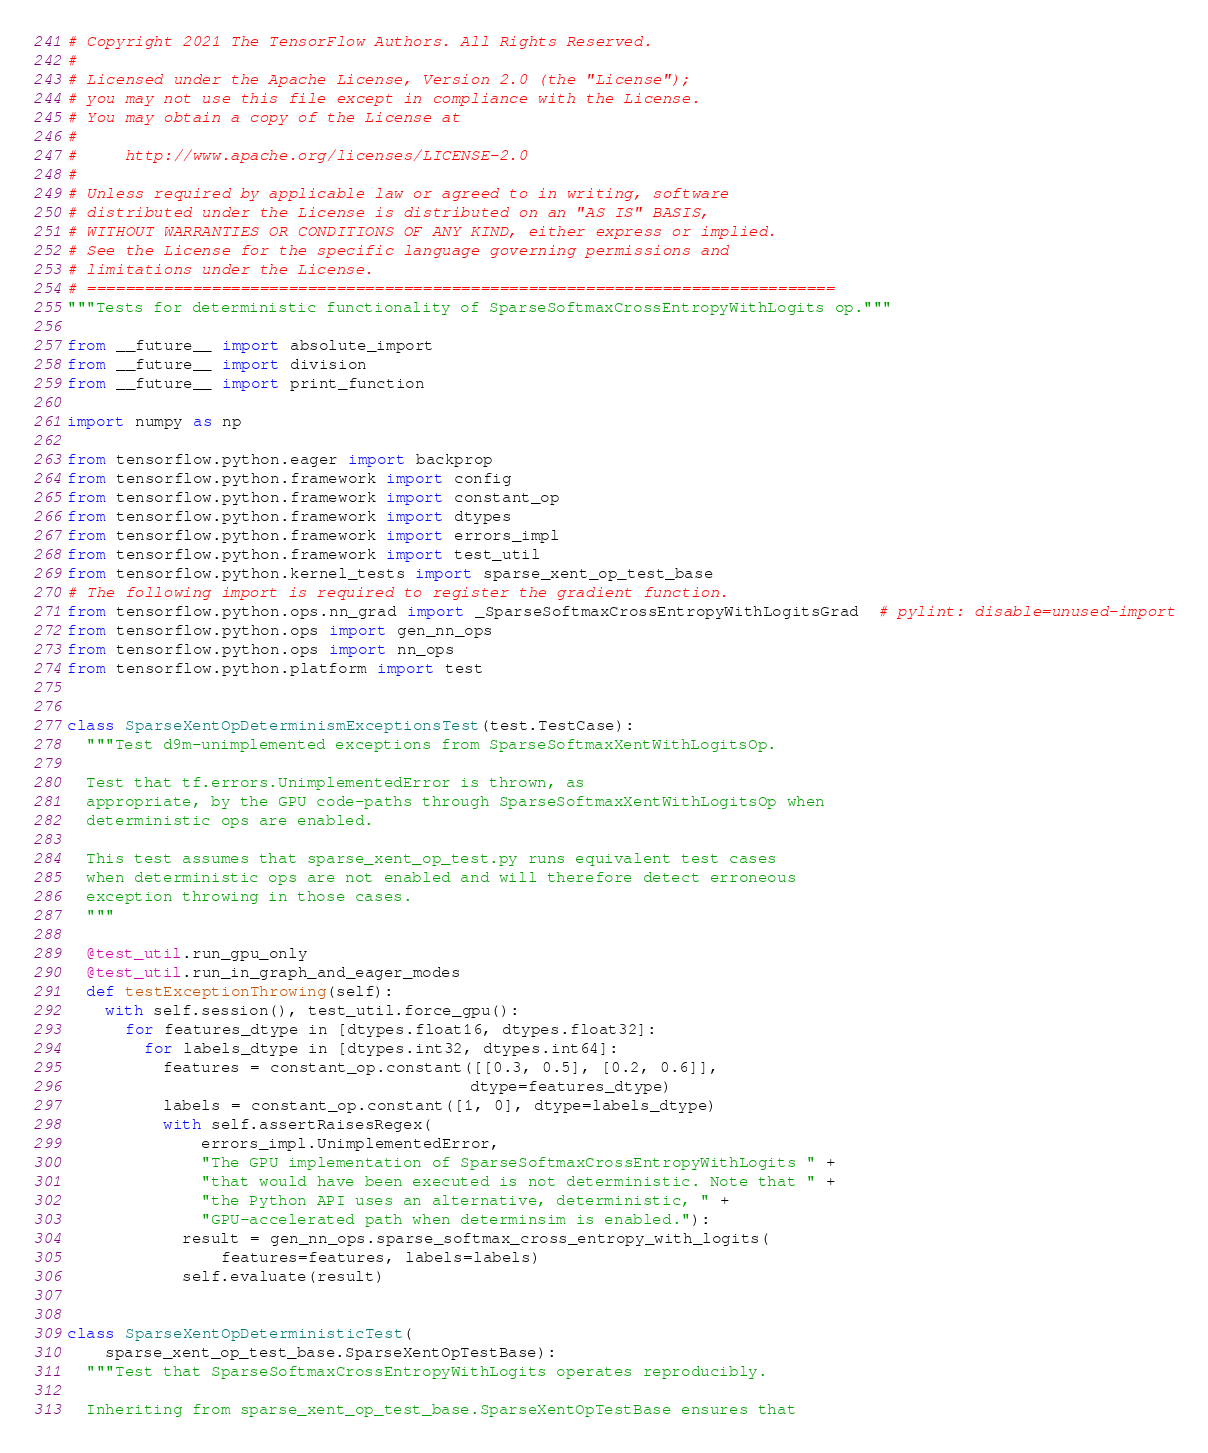Convert code to text. <code><loc_0><loc_0><loc_500><loc_500><_Python_># Copyright 2021 The TensorFlow Authors. All Rights Reserved.
#
# Licensed under the Apache License, Version 2.0 (the "License");
# you may not use this file except in compliance with the License.
# You may obtain a copy of the License at
#
#     http://www.apache.org/licenses/LICENSE-2.0
#
# Unless required by applicable law or agreed to in writing, software
# distributed under the License is distributed on an "AS IS" BASIS,
# WITHOUT WARRANTIES OR CONDITIONS OF ANY KIND, either express or implied.
# See the License for the specific language governing permissions and
# limitations under the License.
# ==============================================================================
"""Tests for deterministic functionality of SparseSoftmaxCrossEntropyWithLogits op."""

from __future__ import absolute_import
from __future__ import division
from __future__ import print_function

import numpy as np

from tensorflow.python.eager import backprop
from tensorflow.python.framework import config
from tensorflow.python.framework import constant_op
from tensorflow.python.framework import dtypes
from tensorflow.python.framework import errors_impl
from tensorflow.python.framework import test_util
from tensorflow.python.kernel_tests import sparse_xent_op_test_base
# The following import is required to register the gradient function.
from tensorflow.python.ops.nn_grad import _SparseSoftmaxCrossEntropyWithLogitsGrad  # pylint: disable=unused-import
from tensorflow.python.ops import gen_nn_ops
from tensorflow.python.ops import nn_ops
from tensorflow.python.platform import test


class SparseXentOpDeterminismExceptionsTest(test.TestCase):
  """Test d9m-unimplemented exceptions from SparseSoftmaxXentWithLogitsOp.

  Test that tf.errors.UnimplementedError is thrown, as
  appropriate, by the GPU code-paths through SparseSoftmaxXentWithLogitsOp when
  deterministic ops are enabled.

  This test assumes that sparse_xent_op_test.py runs equivalent test cases
  when deterministic ops are not enabled and will therefore detect erroneous
  exception throwing in those cases.
  """

  @test_util.run_gpu_only
  @test_util.run_in_graph_and_eager_modes
  def testExceptionThrowing(self):
    with self.session(), test_util.force_gpu():
      for features_dtype in [dtypes.float16, dtypes.float32]:
        for labels_dtype in [dtypes.int32, dtypes.int64]:
          features = constant_op.constant([[0.3, 0.5], [0.2, 0.6]],
                                          dtype=features_dtype)
          labels = constant_op.constant([1, 0], dtype=labels_dtype)
          with self.assertRaisesRegex(
              errors_impl.UnimplementedError,
              "The GPU implementation of SparseSoftmaxCrossEntropyWithLogits " +
              "that would have been executed is not deterministic. Note that " +
              "the Python API uses an alternative, deterministic, " +
              "GPU-accelerated path when determinsim is enabled."):
            result = gen_nn_ops.sparse_softmax_cross_entropy_with_logits(
                features=features, labels=labels)
            self.evaluate(result)


class SparseXentOpDeterministicTest(
    sparse_xent_op_test_base.SparseXentOpTestBase):
  """Test that SparseSoftmaxCrossEntropyWithLogits operates reproducibly.

  Inheriting from sparse_xent_op_test_base.SparseXentOpTestBase ensures that</code> 